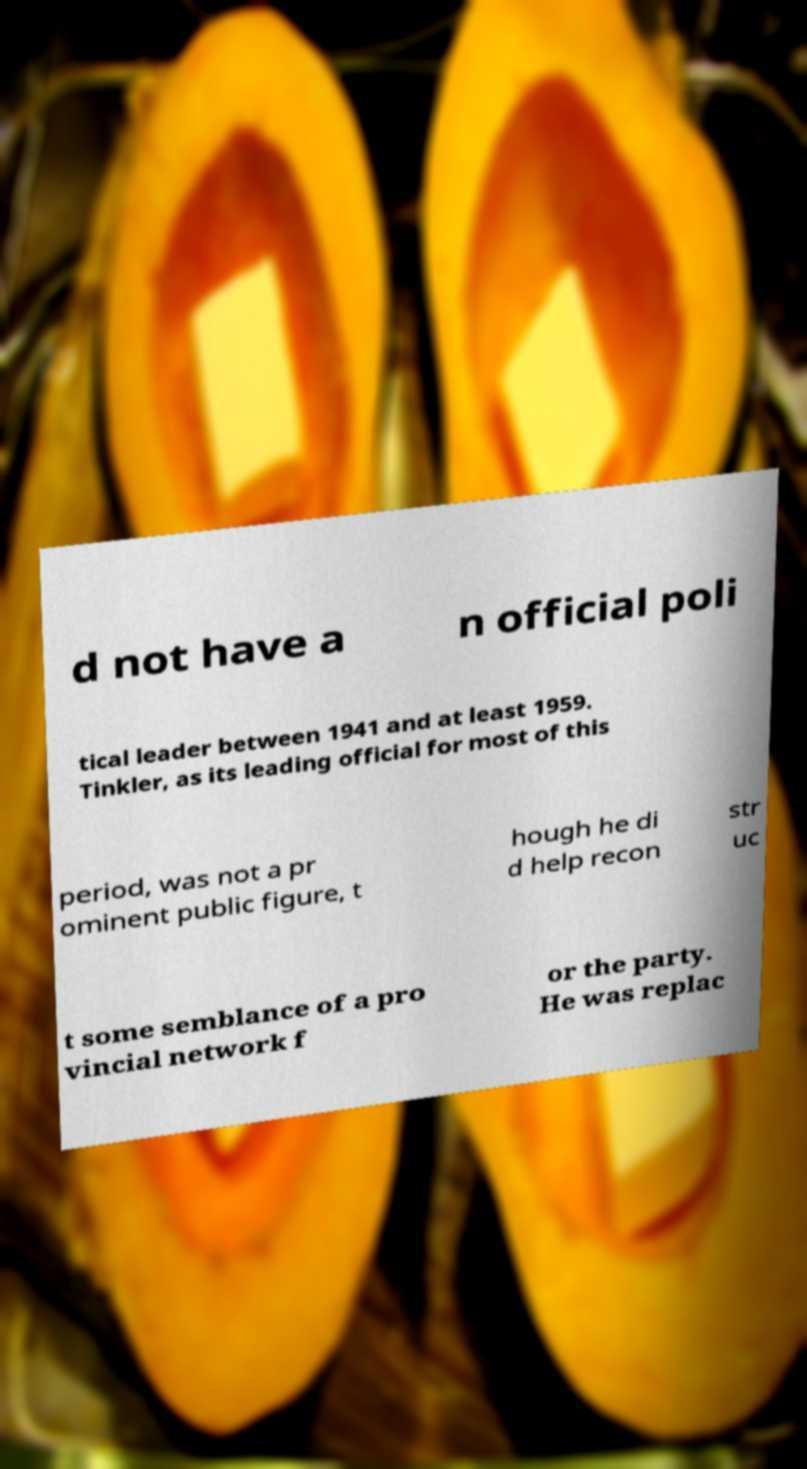Please read and relay the text visible in this image. What does it say? d not have a n official poli tical leader between 1941 and at least 1959. Tinkler, as its leading official for most of this period, was not a pr ominent public figure, t hough he di d help recon str uc t some semblance of a pro vincial network f or the party. He was replac 